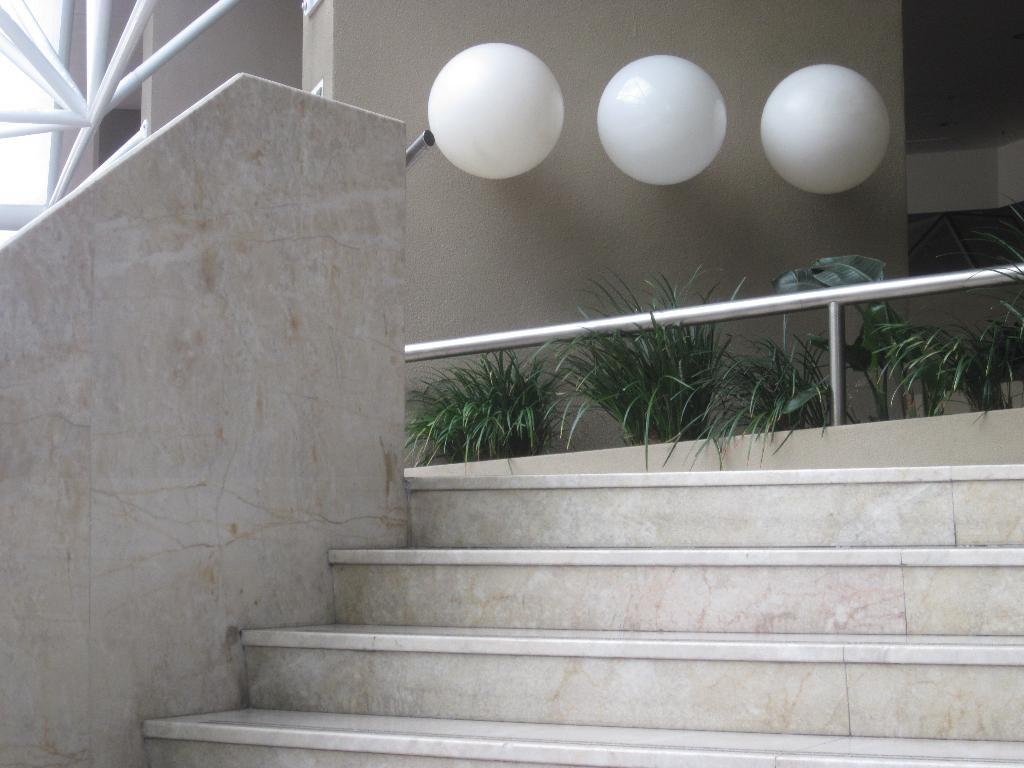What type of architectural feature can be seen in the image? There are staircases in the image. What type of living organisms are present in the image? There are plants in the image. What objects are on the wall in the image? There are white color balls on the wall in the image. Can you tell me how many words are written on the wall in the image? There are no words visible on the wall in the image; only white color balls are present. What type of creature can be seen interacting with the plants in the image? There is no creature present in the image; only staircases, plants, and white color balls are visible. 